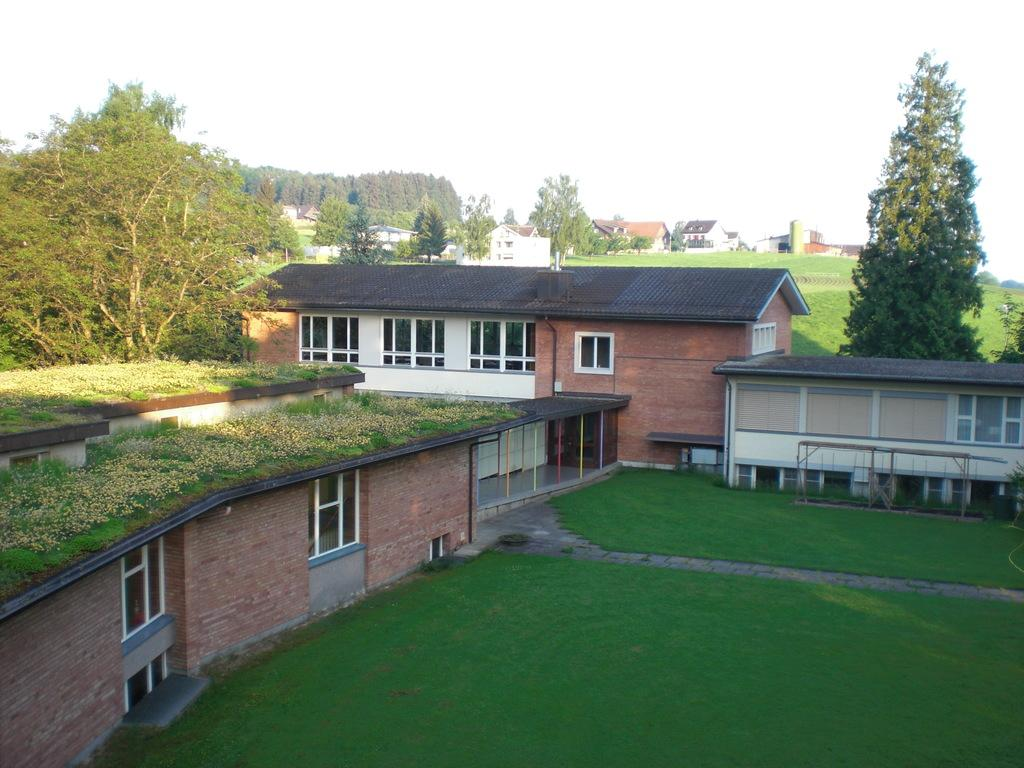What type of vegetation is present on the ground in the image? There is grass on the ground in the front of the image. What can be seen in the distance in the image? There are buildings and trees in the background of the image. What letter is being written in the image? There is no letter being written in the image; it does not depict any writing or text. 